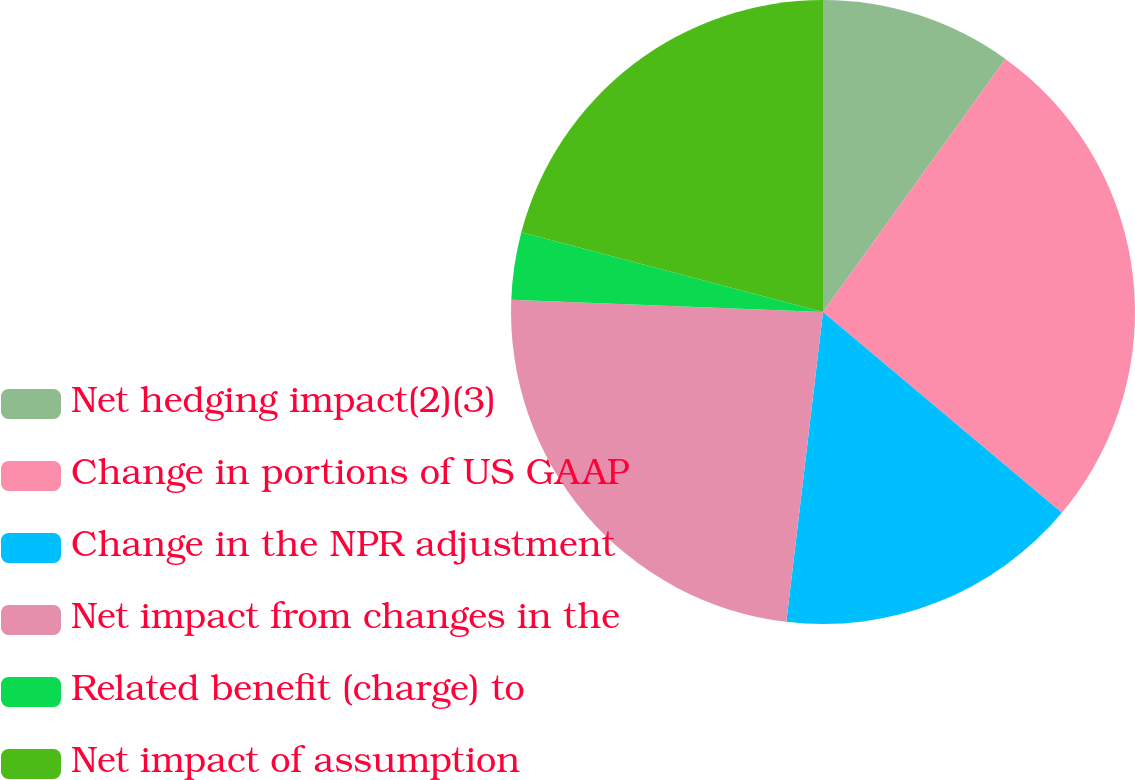<chart> <loc_0><loc_0><loc_500><loc_500><pie_chart><fcel>Net hedging impact(2)(3)<fcel>Change in portions of US GAAP<fcel>Change in the NPR adjustment<fcel>Net impact from changes in the<fcel>Related benefit (charge) to<fcel>Net impact of assumption<nl><fcel>9.94%<fcel>26.19%<fcel>15.75%<fcel>23.75%<fcel>3.49%<fcel>20.89%<nl></chart> 